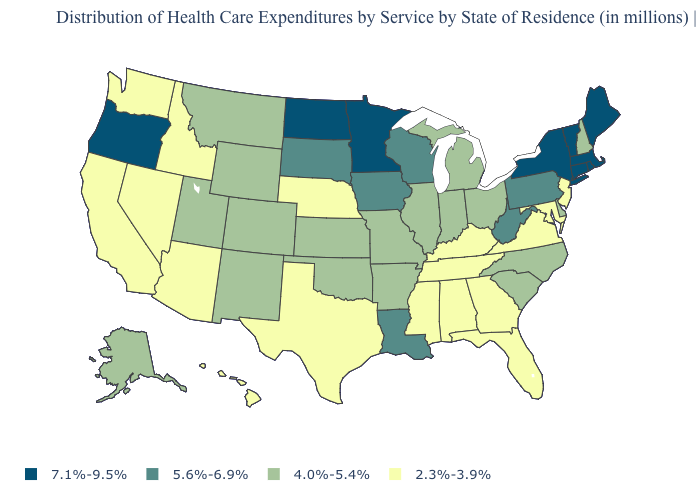What is the value of Illinois?
Short answer required. 4.0%-5.4%. What is the value of Rhode Island?
Quick response, please. 7.1%-9.5%. What is the highest value in the USA?
Quick response, please. 7.1%-9.5%. What is the value of Montana?
Quick response, please. 4.0%-5.4%. Name the states that have a value in the range 5.6%-6.9%?
Keep it brief. Iowa, Louisiana, Pennsylvania, South Dakota, West Virginia, Wisconsin. What is the value of Rhode Island?
Quick response, please. 7.1%-9.5%. Does Delaware have the highest value in the USA?
Be succinct. No. What is the value of Indiana?
Answer briefly. 4.0%-5.4%. What is the value of Hawaii?
Concise answer only. 2.3%-3.9%. What is the value of Alabama?
Give a very brief answer. 2.3%-3.9%. Does Hawaii have the same value as Washington?
Be succinct. Yes. Does West Virginia have a higher value than New York?
Concise answer only. No. Does West Virginia have the highest value in the South?
Be succinct. Yes. Which states have the lowest value in the Northeast?
Short answer required. New Jersey. Name the states that have a value in the range 7.1%-9.5%?
Write a very short answer. Connecticut, Maine, Massachusetts, Minnesota, New York, North Dakota, Oregon, Rhode Island, Vermont. 